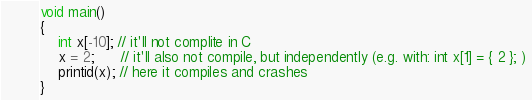Convert code to text. <code><loc_0><loc_0><loc_500><loc_500><_C_>void main() 
{
	int x[-10]; // it'll not complite in C
	x = 2;      // it'll also not compile, but independently (e.g. with: int x[1] = { 2 }; )
	printid(x); // here it compiles and crashes
}</code> 